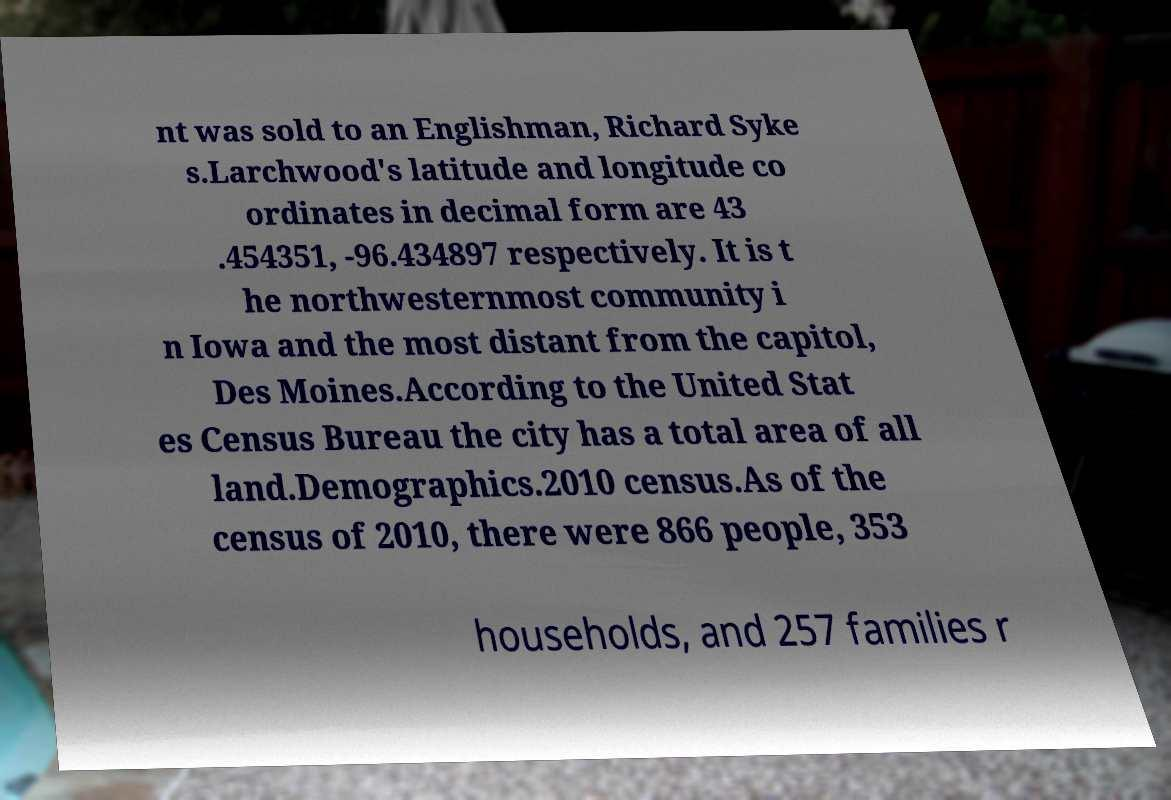What messages or text are displayed in this image? I need them in a readable, typed format. nt was sold to an Englishman, Richard Syke s.Larchwood's latitude and longitude co ordinates in decimal form are 43 .454351, -96.434897 respectively. It is t he northwesternmost community i n Iowa and the most distant from the capitol, Des Moines.According to the United Stat es Census Bureau the city has a total area of all land.Demographics.2010 census.As of the census of 2010, there were 866 people, 353 households, and 257 families r 